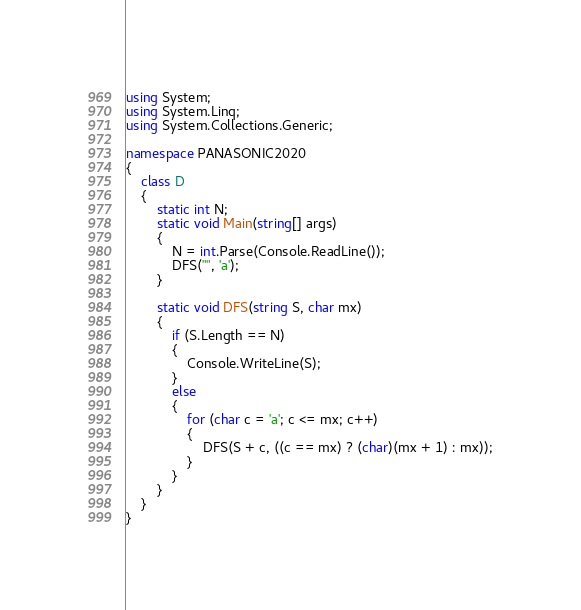<code> <loc_0><loc_0><loc_500><loc_500><_C#_>using System;
using System.Linq;
using System.Collections.Generic;

namespace PANASONIC2020
{
    class D
    {
        static int N;
        static void Main(string[] args)
        {
            N = int.Parse(Console.ReadLine());
            DFS("", 'a');
        }

        static void DFS(string S, char mx)
        {
            if (S.Length == N)
            {
                Console.WriteLine(S);
            }
            else
            {
                for (char c = 'a'; c <= mx; c++)
                {
                    DFS(S + c, ((c == mx) ? (char)(mx + 1) : mx));
                }
            }
        }
    }
}
</code> 